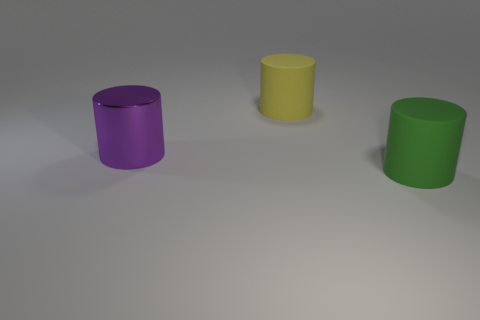How many objects are large green rubber things or matte cylinders that are behind the purple shiny cylinder?
Make the answer very short. 2. Is the number of large objects behind the yellow rubber thing less than the number of small gray rubber cylinders?
Your response must be concise. No. There is a cylinder that is to the left of the big object behind the big purple shiny cylinder to the left of the big yellow matte thing; what is its size?
Your answer should be very brief. Large. What color is the object that is left of the green matte cylinder and in front of the large yellow thing?
Your answer should be compact. Purple. What number of cylinders are there?
Ensure brevity in your answer.  3. Are there any other things that are the same size as the yellow rubber object?
Your answer should be compact. Yes. Is the yellow cylinder made of the same material as the green cylinder?
Provide a succinct answer. Yes. Do the cylinder that is left of the yellow rubber cylinder and the cylinder that is right of the yellow matte cylinder have the same size?
Keep it short and to the point. Yes. Is the number of large rubber objects less than the number of purple metal cylinders?
Your response must be concise. No. How many shiny things are big yellow things or purple things?
Give a very brief answer. 1. 